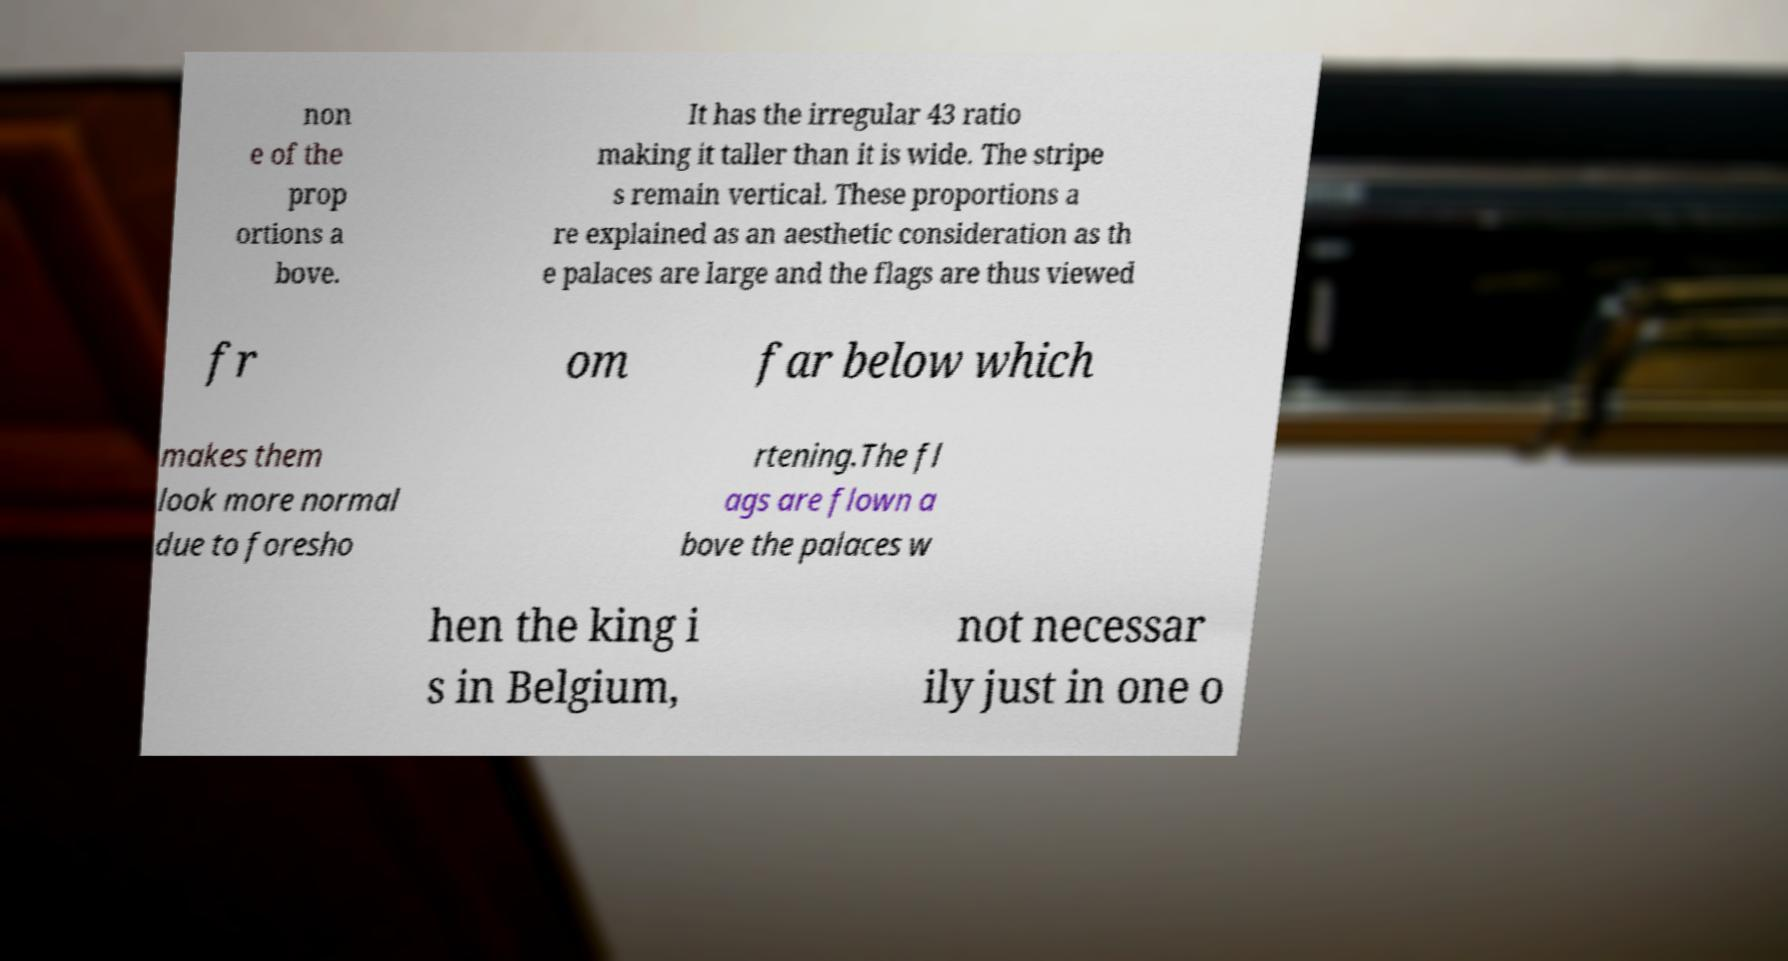There's text embedded in this image that I need extracted. Can you transcribe it verbatim? non e of the prop ortions a bove. It has the irregular 43 ratio making it taller than it is wide. The stripe s remain vertical. These proportions a re explained as an aesthetic consideration as th e palaces are large and the flags are thus viewed fr om far below which makes them look more normal due to foresho rtening.The fl ags are flown a bove the palaces w hen the king i s in Belgium, not necessar ily just in one o 